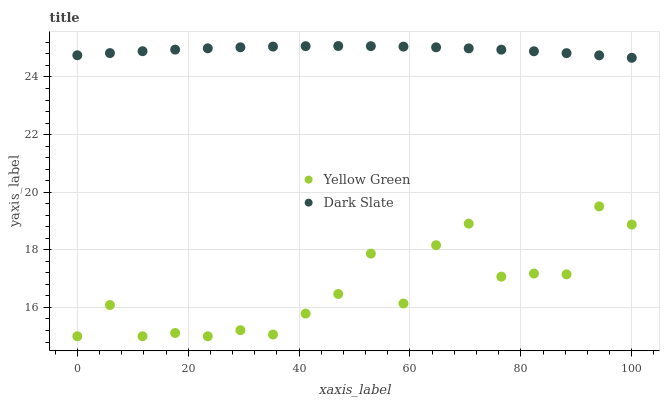Does Yellow Green have the minimum area under the curve?
Answer yes or no. Yes. Does Dark Slate have the maximum area under the curve?
Answer yes or no. Yes. Does Yellow Green have the maximum area under the curve?
Answer yes or no. No. Is Dark Slate the smoothest?
Answer yes or no. Yes. Is Yellow Green the roughest?
Answer yes or no. Yes. Is Yellow Green the smoothest?
Answer yes or no. No. Does Yellow Green have the lowest value?
Answer yes or no. Yes. Does Dark Slate have the highest value?
Answer yes or no. Yes. Does Yellow Green have the highest value?
Answer yes or no. No. Is Yellow Green less than Dark Slate?
Answer yes or no. Yes. Is Dark Slate greater than Yellow Green?
Answer yes or no. Yes. Does Yellow Green intersect Dark Slate?
Answer yes or no. No. 